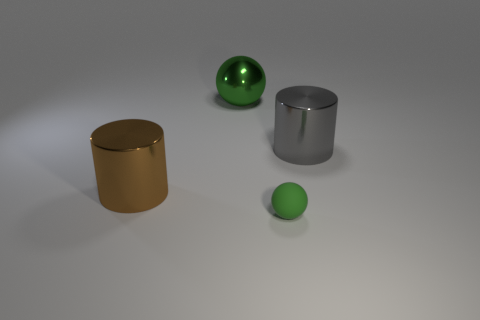Are there any other things that have the same size as the rubber object?
Offer a terse response. No. Do the green thing that is behind the big brown metallic cylinder and the green thing that is in front of the big gray cylinder have the same shape?
Give a very brief answer. Yes. There is a big object that is left of the rubber ball and to the right of the large brown shiny cylinder; what color is it?
Keep it short and to the point. Green. Does the sphere in front of the green metal object have the same size as the brown object behind the tiny matte ball?
Offer a very short reply. No. What number of rubber objects are the same color as the large ball?
Give a very brief answer. 1. What number of big objects are either green rubber things or blue shiny balls?
Your response must be concise. 0. Are the large object right of the large green ball and the tiny green thing made of the same material?
Make the answer very short. No. There is a metallic cylinder to the left of the gray thing; what color is it?
Your answer should be very brief. Brown. Is there a purple rubber block that has the same size as the green metal object?
Provide a short and direct response. No. What is the material of the brown object that is the same size as the green metallic object?
Your response must be concise. Metal. 